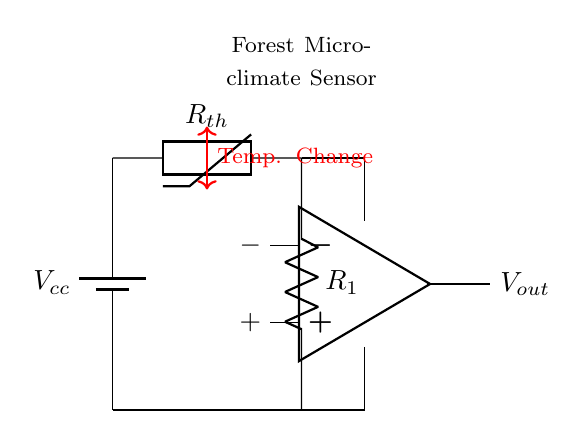What component is used to measure temperature? The thermistor is the component specifically designed to measure temperature changes. In the circuit, it is labeled as Rth.
Answer: thermistor What is the purpose of R1 in the circuit? Resistor R1 is part of a voltage divider configuration that helps to stabilize the output voltage by providing a reference point against the thermistor's resistance changes due to temperature.
Answer: voltage divider How many outputs does the op-amp have? The op-amp in the circuit has two outputs, labeled as positive and negative terminals. This allows the op-amp to amplify the voltage difference between its input terminals.
Answer: two What is the role of the battery in this circuit? The battery serves as the power supply for the entire circuit, providing the necessary voltage (denoted as Vcc) for operating the components.
Answer: power supply What does Vout represent in the circuit? Vout represents the output voltage of the op-amp, which is dependent on the voltage from the thermistor and the reference voltage set by R1.
Answer: output voltage Which component directly senses temperature changes? The thermistor directly senses temperature changes as its resistance varies with temperature. This resistance change is used to measure the environmental temperature.
Answer: thermistor What happens when the temperature increases in this circuit? When the temperature increases, the resistance of the thermistor decreases, leading to a change in output voltage from the op-amp. This output voltage reflects the temperature change detected by the thermistor.
Answer: output voltage increases 